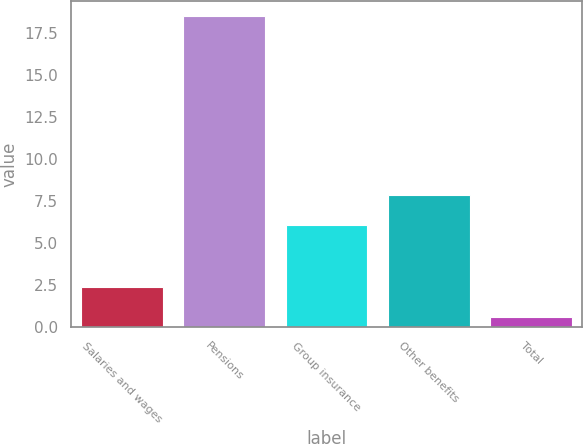Convert chart. <chart><loc_0><loc_0><loc_500><loc_500><bar_chart><fcel>Salaries and wages<fcel>Pensions<fcel>Group insurance<fcel>Other benefits<fcel>Total<nl><fcel>2.39<fcel>18.5<fcel>6.1<fcel>7.89<fcel>0.6<nl></chart> 